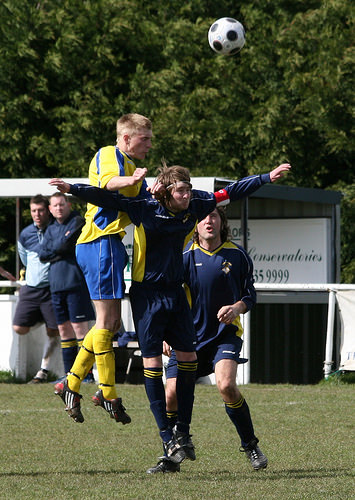<image>
Is there a soccer ball in front of the trees? Yes. The soccer ball is positioned in front of the trees, appearing closer to the camera viewpoint. 